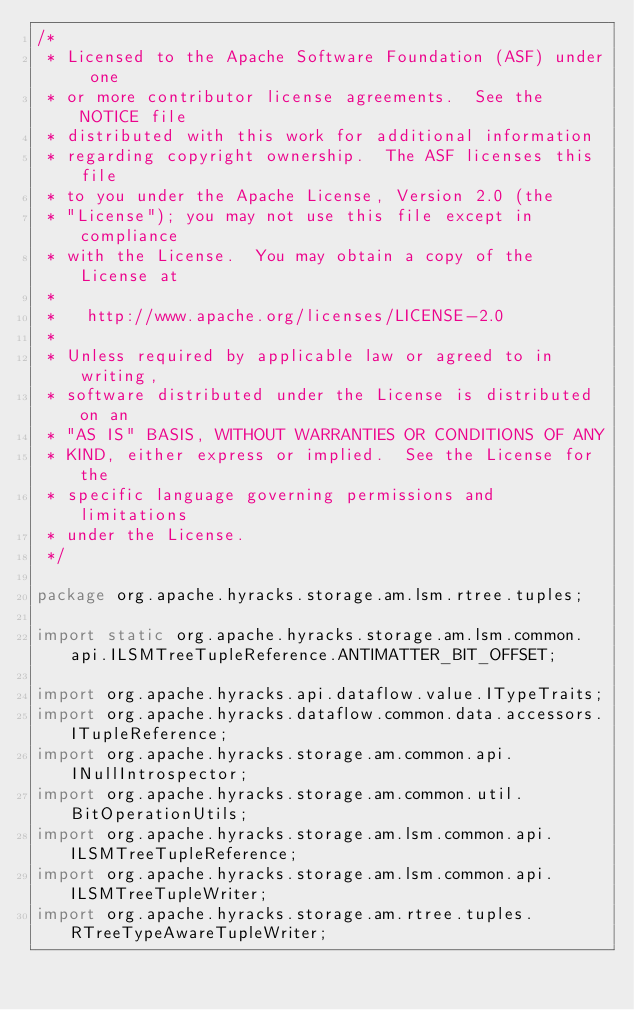Convert code to text. <code><loc_0><loc_0><loc_500><loc_500><_Java_>/*
 * Licensed to the Apache Software Foundation (ASF) under one
 * or more contributor license agreements.  See the NOTICE file
 * distributed with this work for additional information
 * regarding copyright ownership.  The ASF licenses this file
 * to you under the Apache License, Version 2.0 (the
 * "License"); you may not use this file except in compliance
 * with the License.  You may obtain a copy of the License at
 *
 *   http://www.apache.org/licenses/LICENSE-2.0
 *
 * Unless required by applicable law or agreed to in writing,
 * software distributed under the License is distributed on an
 * "AS IS" BASIS, WITHOUT WARRANTIES OR CONDITIONS OF ANY
 * KIND, either express or implied.  See the License for the
 * specific language governing permissions and limitations
 * under the License.
 */

package org.apache.hyracks.storage.am.lsm.rtree.tuples;

import static org.apache.hyracks.storage.am.lsm.common.api.ILSMTreeTupleReference.ANTIMATTER_BIT_OFFSET;

import org.apache.hyracks.api.dataflow.value.ITypeTraits;
import org.apache.hyracks.dataflow.common.data.accessors.ITupleReference;
import org.apache.hyracks.storage.am.common.api.INullIntrospector;
import org.apache.hyracks.storage.am.common.util.BitOperationUtils;
import org.apache.hyracks.storage.am.lsm.common.api.ILSMTreeTupleReference;
import org.apache.hyracks.storage.am.lsm.common.api.ILSMTreeTupleWriter;
import org.apache.hyracks.storage.am.rtree.tuples.RTreeTypeAwareTupleWriter;</code> 